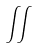Convert formula to latex. <formula><loc_0><loc_0><loc_500><loc_500>\iint</formula> 